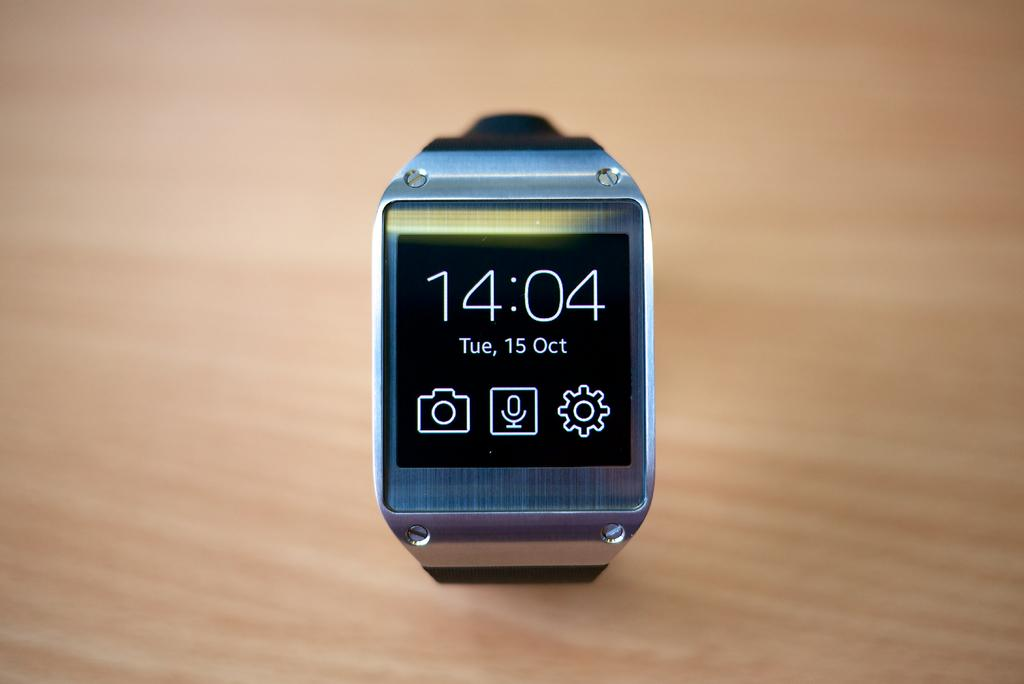Provide a one-sentence caption for the provided image. A GRAY COLORED SMART WATCH WITH THE TIME 14:04. 